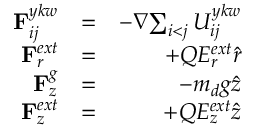<formula> <loc_0><loc_0><loc_500><loc_500>\begin{array} { r l r } { { { F } _ { i j } ^ { y k w } } } & { = } & { - { \nabla } { \sum _ { \substack { i < j } } { { U } _ { i j } ^ { y k w } } } } \\ { { { F } _ { r } ^ { e x t } } } & { = } & { + { Q } { E _ { r } ^ { e x t } } { \hat { r } } } \\ { { { F } _ { z } ^ { g } } } & { = } & { - { { m _ { d } } g { \hat { z } } } } \\ { { { F } _ { z } ^ { e x t } } } & { = } & { + { Q } { E _ { z } ^ { e x t } } { \hat { z } } } \end{array}</formula> 